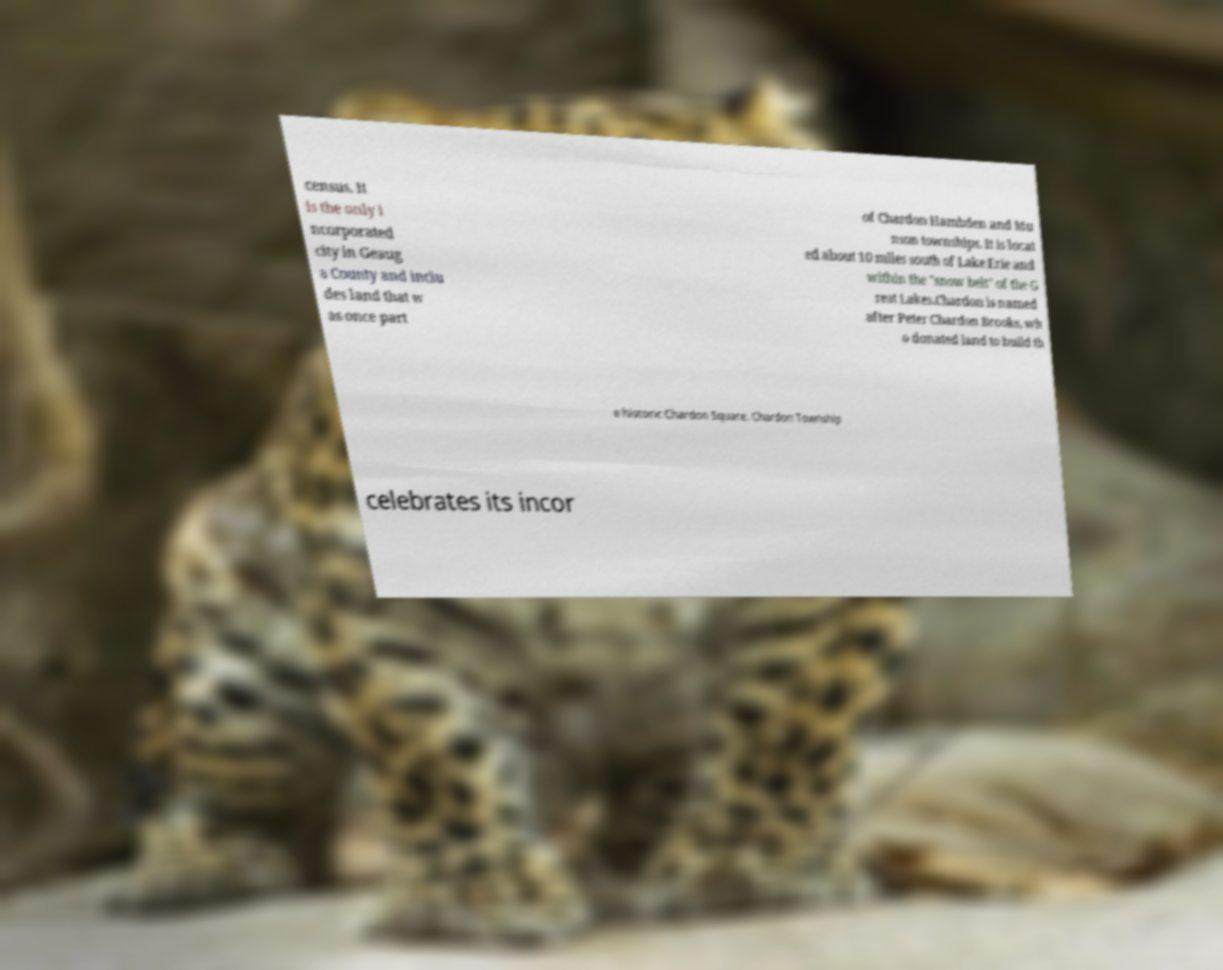There's text embedded in this image that I need extracted. Can you transcribe it verbatim? census. It is the only i ncorporated city in Geaug a County and inclu des land that w as once part of Chardon Hambden and Mu nson townships. It is locat ed about 10 miles south of Lake Erie and within the "snow belt" of the G reat Lakes.Chardon is named after Peter Chardon Brooks, wh o donated land to build th e historic Chardon Square. Chardon Township celebrates its incor 